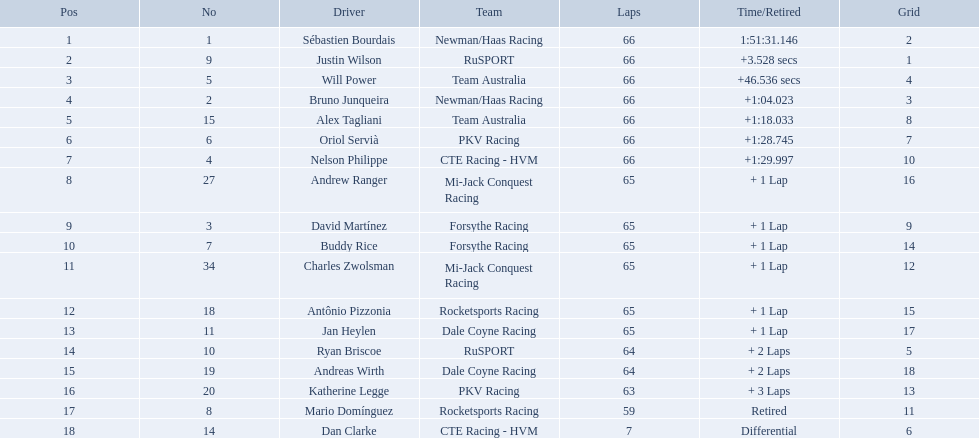Who are all the drivers? Sébastien Bourdais, Justin Wilson, Will Power, Bruno Junqueira, Alex Tagliani, Oriol Servià, Nelson Philippe, Andrew Ranger, David Martínez, Buddy Rice, Charles Zwolsman, Antônio Pizzonia, Jan Heylen, Ryan Briscoe, Andreas Wirth, Katherine Legge, Mario Domínguez, Dan Clarke. What position did they reach? 1, 2, 3, 4, 5, 6, 7, 8, 9, 10, 11, 12, 13, 14, 15, 16, 17, 18. What is the number for each driver? 1, 9, 5, 2, 15, 6, 4, 27, 3, 7, 34, 18, 11, 10, 19, 20, 8, 14. And which player's number and position match? Sébastien Bourdais. 